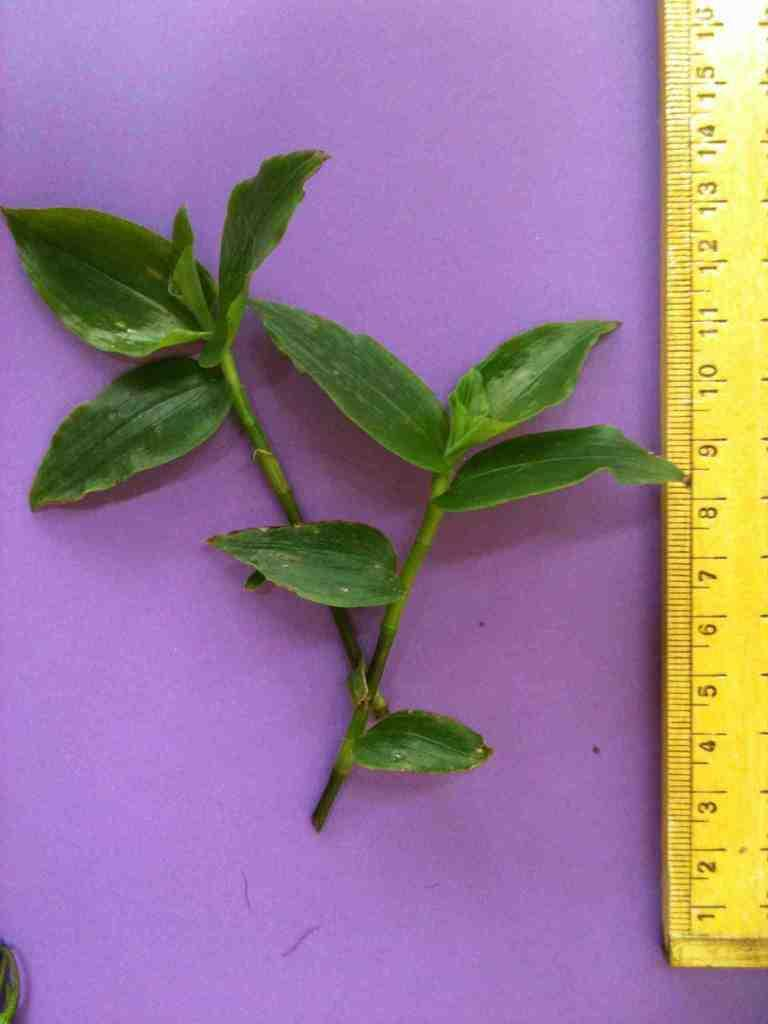<image>
Summarize the visual content of the image. A leafy twig being measured against a yellow ruler from 1 to 15 cm. 